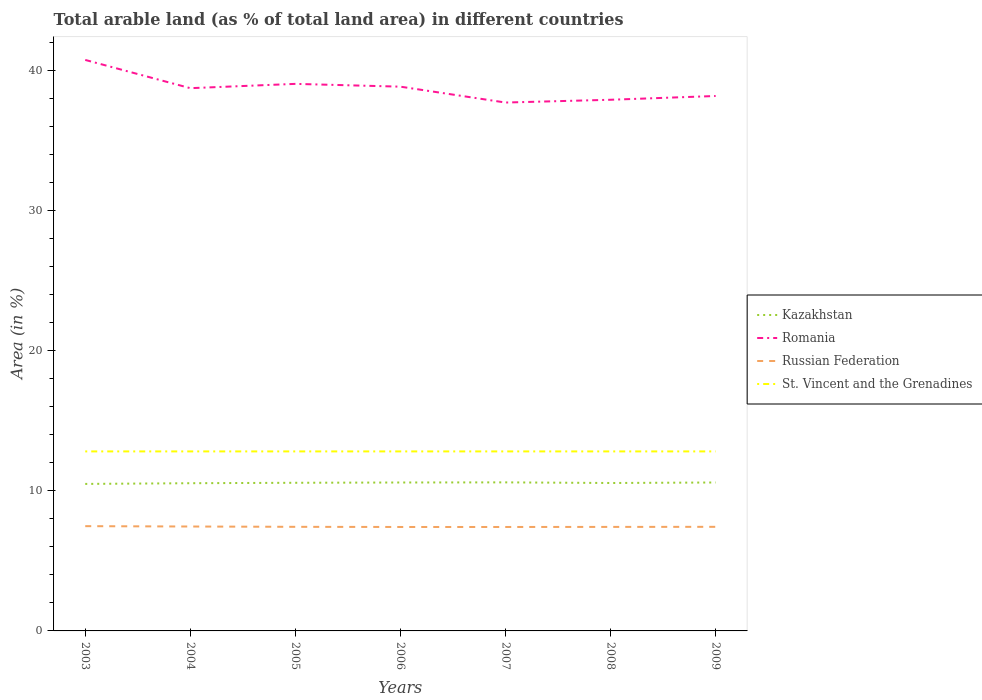How many different coloured lines are there?
Ensure brevity in your answer.  4. Across all years, what is the maximum percentage of arable land in Romania?
Your answer should be very brief. 37.74. In which year was the percentage of arable land in St. Vincent and the Grenadines maximum?
Provide a succinct answer. 2003. What is the total percentage of arable land in Russian Federation in the graph?
Keep it short and to the point. 0.01. What is the difference between the highest and the second highest percentage of arable land in Russian Federation?
Your answer should be very brief. 0.06. What is the difference between the highest and the lowest percentage of arable land in Kazakhstan?
Your answer should be compact. 4. Is the percentage of arable land in Romania strictly greater than the percentage of arable land in Kazakhstan over the years?
Provide a succinct answer. No. How many lines are there?
Your response must be concise. 4. How many years are there in the graph?
Provide a short and direct response. 7. What is the difference between two consecutive major ticks on the Y-axis?
Ensure brevity in your answer.  10. Does the graph contain any zero values?
Ensure brevity in your answer.  No. How many legend labels are there?
Offer a very short reply. 4. What is the title of the graph?
Offer a terse response. Total arable land (as % of total land area) in different countries. Does "Greece" appear as one of the legend labels in the graph?
Offer a very short reply. No. What is the label or title of the Y-axis?
Offer a very short reply. Area (in %). What is the Area (in %) in Kazakhstan in 2003?
Provide a succinct answer. 10.5. What is the Area (in %) in Romania in 2003?
Give a very brief answer. 40.78. What is the Area (in %) of Russian Federation in 2003?
Keep it short and to the point. 7.48. What is the Area (in %) in St. Vincent and the Grenadines in 2003?
Provide a short and direct response. 12.82. What is the Area (in %) of Kazakhstan in 2004?
Provide a succinct answer. 10.55. What is the Area (in %) in Romania in 2004?
Keep it short and to the point. 38.76. What is the Area (in %) in Russian Federation in 2004?
Your response must be concise. 7.46. What is the Area (in %) in St. Vincent and the Grenadines in 2004?
Provide a succinct answer. 12.82. What is the Area (in %) in Kazakhstan in 2005?
Your response must be concise. 10.58. What is the Area (in %) in Romania in 2005?
Your answer should be very brief. 39.07. What is the Area (in %) of Russian Federation in 2005?
Your response must be concise. 7.43. What is the Area (in %) in St. Vincent and the Grenadines in 2005?
Offer a terse response. 12.82. What is the Area (in %) of Kazakhstan in 2006?
Provide a succinct answer. 10.6. What is the Area (in %) of Romania in 2006?
Offer a terse response. 38.87. What is the Area (in %) of Russian Federation in 2006?
Offer a terse response. 7.42. What is the Area (in %) in St. Vincent and the Grenadines in 2006?
Keep it short and to the point. 12.82. What is the Area (in %) in Kazakhstan in 2007?
Your answer should be very brief. 10.61. What is the Area (in %) of Romania in 2007?
Make the answer very short. 37.74. What is the Area (in %) of Russian Federation in 2007?
Ensure brevity in your answer.  7.42. What is the Area (in %) in St. Vincent and the Grenadines in 2007?
Ensure brevity in your answer.  12.82. What is the Area (in %) in Kazakhstan in 2008?
Give a very brief answer. 10.56. What is the Area (in %) of Romania in 2008?
Your response must be concise. 37.93. What is the Area (in %) of Russian Federation in 2008?
Give a very brief answer. 7.43. What is the Area (in %) in St. Vincent and the Grenadines in 2008?
Offer a very short reply. 12.82. What is the Area (in %) of Kazakhstan in 2009?
Your response must be concise. 10.6. What is the Area (in %) of Romania in 2009?
Your answer should be compact. 38.2. What is the Area (in %) in Russian Federation in 2009?
Your answer should be very brief. 7.43. What is the Area (in %) of St. Vincent and the Grenadines in 2009?
Provide a succinct answer. 12.82. Across all years, what is the maximum Area (in %) of Kazakhstan?
Make the answer very short. 10.61. Across all years, what is the maximum Area (in %) of Romania?
Make the answer very short. 40.78. Across all years, what is the maximum Area (in %) in Russian Federation?
Your answer should be very brief. 7.48. Across all years, what is the maximum Area (in %) of St. Vincent and the Grenadines?
Your answer should be compact. 12.82. Across all years, what is the minimum Area (in %) in Kazakhstan?
Your answer should be compact. 10.5. Across all years, what is the minimum Area (in %) in Romania?
Provide a short and direct response. 37.74. Across all years, what is the minimum Area (in %) of Russian Federation?
Make the answer very short. 7.42. Across all years, what is the minimum Area (in %) of St. Vincent and the Grenadines?
Your answer should be compact. 12.82. What is the total Area (in %) in Kazakhstan in the graph?
Offer a very short reply. 74. What is the total Area (in %) in Romania in the graph?
Ensure brevity in your answer.  271.35. What is the total Area (in %) of Russian Federation in the graph?
Provide a short and direct response. 52.08. What is the total Area (in %) of St. Vincent and the Grenadines in the graph?
Your answer should be very brief. 89.74. What is the difference between the Area (in %) of Kazakhstan in 2003 and that in 2004?
Provide a succinct answer. -0.05. What is the difference between the Area (in %) in Romania in 2003 and that in 2004?
Provide a succinct answer. 2.02. What is the difference between the Area (in %) of Russian Federation in 2003 and that in 2004?
Offer a very short reply. 0.03. What is the difference between the Area (in %) of St. Vincent and the Grenadines in 2003 and that in 2004?
Offer a very short reply. 0. What is the difference between the Area (in %) in Kazakhstan in 2003 and that in 2005?
Give a very brief answer. -0.08. What is the difference between the Area (in %) of Romania in 2003 and that in 2005?
Give a very brief answer. 1.71. What is the difference between the Area (in %) in Russian Federation in 2003 and that in 2005?
Your answer should be very brief. 0.05. What is the difference between the Area (in %) in Kazakhstan in 2003 and that in 2006?
Keep it short and to the point. -0.1. What is the difference between the Area (in %) in Romania in 2003 and that in 2006?
Offer a terse response. 1.91. What is the difference between the Area (in %) of Russian Federation in 2003 and that in 2006?
Your response must be concise. 0.06. What is the difference between the Area (in %) in St. Vincent and the Grenadines in 2003 and that in 2006?
Keep it short and to the point. 0. What is the difference between the Area (in %) of Kazakhstan in 2003 and that in 2007?
Provide a short and direct response. -0.11. What is the difference between the Area (in %) of Romania in 2003 and that in 2007?
Ensure brevity in your answer.  3.04. What is the difference between the Area (in %) of Russian Federation in 2003 and that in 2007?
Your answer should be very brief. 0.06. What is the difference between the Area (in %) of St. Vincent and the Grenadines in 2003 and that in 2007?
Your answer should be very brief. 0. What is the difference between the Area (in %) in Kazakhstan in 2003 and that in 2008?
Offer a very short reply. -0.07. What is the difference between the Area (in %) of Romania in 2003 and that in 2008?
Your answer should be very brief. 2.84. What is the difference between the Area (in %) in Russian Federation in 2003 and that in 2008?
Your answer should be very brief. 0.05. What is the difference between the Area (in %) in St. Vincent and the Grenadines in 2003 and that in 2008?
Your answer should be compact. 0. What is the difference between the Area (in %) in Kazakhstan in 2003 and that in 2009?
Keep it short and to the point. -0.1. What is the difference between the Area (in %) of Romania in 2003 and that in 2009?
Offer a very short reply. 2.58. What is the difference between the Area (in %) of Russian Federation in 2003 and that in 2009?
Make the answer very short. 0.05. What is the difference between the Area (in %) of Kazakhstan in 2004 and that in 2005?
Keep it short and to the point. -0.03. What is the difference between the Area (in %) of Romania in 2004 and that in 2005?
Provide a succinct answer. -0.31. What is the difference between the Area (in %) of Russian Federation in 2004 and that in 2005?
Ensure brevity in your answer.  0.02. What is the difference between the Area (in %) in St. Vincent and the Grenadines in 2004 and that in 2005?
Keep it short and to the point. 0. What is the difference between the Area (in %) of Kazakhstan in 2004 and that in 2006?
Your answer should be compact. -0.05. What is the difference between the Area (in %) in Romania in 2004 and that in 2006?
Your answer should be very brief. -0.11. What is the difference between the Area (in %) of Kazakhstan in 2004 and that in 2007?
Offer a terse response. -0.06. What is the difference between the Area (in %) of Romania in 2004 and that in 2007?
Your answer should be compact. 1.03. What is the difference between the Area (in %) in St. Vincent and the Grenadines in 2004 and that in 2007?
Provide a succinct answer. 0. What is the difference between the Area (in %) of Kazakhstan in 2004 and that in 2008?
Offer a terse response. -0.02. What is the difference between the Area (in %) of Romania in 2004 and that in 2008?
Your answer should be very brief. 0.83. What is the difference between the Area (in %) of Russian Federation in 2004 and that in 2008?
Ensure brevity in your answer.  0.03. What is the difference between the Area (in %) in Kazakhstan in 2004 and that in 2009?
Provide a short and direct response. -0.05. What is the difference between the Area (in %) of Romania in 2004 and that in 2009?
Offer a very short reply. 0.56. What is the difference between the Area (in %) in Russian Federation in 2004 and that in 2009?
Your response must be concise. 0.02. What is the difference between the Area (in %) of Kazakhstan in 2005 and that in 2006?
Your response must be concise. -0.02. What is the difference between the Area (in %) in Russian Federation in 2005 and that in 2006?
Your answer should be compact. 0.01. What is the difference between the Area (in %) in St. Vincent and the Grenadines in 2005 and that in 2006?
Keep it short and to the point. 0. What is the difference between the Area (in %) in Kazakhstan in 2005 and that in 2007?
Ensure brevity in your answer.  -0.03. What is the difference between the Area (in %) of Romania in 2005 and that in 2007?
Give a very brief answer. 1.33. What is the difference between the Area (in %) of Russian Federation in 2005 and that in 2007?
Offer a terse response. 0.01. What is the difference between the Area (in %) of Kazakhstan in 2005 and that in 2008?
Ensure brevity in your answer.  0.02. What is the difference between the Area (in %) in Romania in 2005 and that in 2008?
Keep it short and to the point. 1.13. What is the difference between the Area (in %) in Russian Federation in 2005 and that in 2008?
Your response must be concise. 0.01. What is the difference between the Area (in %) of Kazakhstan in 2005 and that in 2009?
Provide a succinct answer. -0.02. What is the difference between the Area (in %) of Romania in 2005 and that in 2009?
Make the answer very short. 0.87. What is the difference between the Area (in %) of Russian Federation in 2005 and that in 2009?
Provide a succinct answer. -0. What is the difference between the Area (in %) in Kazakhstan in 2006 and that in 2007?
Give a very brief answer. -0.01. What is the difference between the Area (in %) of Romania in 2006 and that in 2007?
Your answer should be very brief. 1.13. What is the difference between the Area (in %) in Russian Federation in 2006 and that in 2007?
Make the answer very short. 0. What is the difference between the Area (in %) in St. Vincent and the Grenadines in 2006 and that in 2007?
Your response must be concise. 0. What is the difference between the Area (in %) of Kazakhstan in 2006 and that in 2008?
Provide a short and direct response. 0.04. What is the difference between the Area (in %) of Romania in 2006 and that in 2008?
Give a very brief answer. 0.93. What is the difference between the Area (in %) in Russian Federation in 2006 and that in 2008?
Keep it short and to the point. -0.01. What is the difference between the Area (in %) in St. Vincent and the Grenadines in 2006 and that in 2008?
Offer a terse response. 0. What is the difference between the Area (in %) in Kazakhstan in 2006 and that in 2009?
Provide a short and direct response. -0. What is the difference between the Area (in %) in Romania in 2006 and that in 2009?
Make the answer very short. 0.67. What is the difference between the Area (in %) of Russian Federation in 2006 and that in 2009?
Give a very brief answer. -0.01. What is the difference between the Area (in %) of St. Vincent and the Grenadines in 2006 and that in 2009?
Offer a very short reply. 0. What is the difference between the Area (in %) in Kazakhstan in 2007 and that in 2008?
Your answer should be compact. 0.04. What is the difference between the Area (in %) in Romania in 2007 and that in 2008?
Provide a succinct answer. -0.2. What is the difference between the Area (in %) in Russian Federation in 2007 and that in 2008?
Keep it short and to the point. -0.01. What is the difference between the Area (in %) of St. Vincent and the Grenadines in 2007 and that in 2008?
Your answer should be very brief. 0. What is the difference between the Area (in %) in Kazakhstan in 2007 and that in 2009?
Offer a terse response. 0.01. What is the difference between the Area (in %) in Romania in 2007 and that in 2009?
Provide a short and direct response. -0.47. What is the difference between the Area (in %) in Russian Federation in 2007 and that in 2009?
Make the answer very short. -0.01. What is the difference between the Area (in %) in St. Vincent and the Grenadines in 2007 and that in 2009?
Offer a very short reply. 0. What is the difference between the Area (in %) of Kazakhstan in 2008 and that in 2009?
Your answer should be very brief. -0.04. What is the difference between the Area (in %) in Romania in 2008 and that in 2009?
Your answer should be compact. -0.27. What is the difference between the Area (in %) in Russian Federation in 2008 and that in 2009?
Offer a very short reply. -0.01. What is the difference between the Area (in %) in St. Vincent and the Grenadines in 2008 and that in 2009?
Your answer should be very brief. 0. What is the difference between the Area (in %) in Kazakhstan in 2003 and the Area (in %) in Romania in 2004?
Offer a very short reply. -28.26. What is the difference between the Area (in %) of Kazakhstan in 2003 and the Area (in %) of Russian Federation in 2004?
Provide a succinct answer. 3.04. What is the difference between the Area (in %) in Kazakhstan in 2003 and the Area (in %) in St. Vincent and the Grenadines in 2004?
Your answer should be compact. -2.32. What is the difference between the Area (in %) of Romania in 2003 and the Area (in %) of Russian Federation in 2004?
Your answer should be very brief. 33.32. What is the difference between the Area (in %) of Romania in 2003 and the Area (in %) of St. Vincent and the Grenadines in 2004?
Your response must be concise. 27.96. What is the difference between the Area (in %) of Russian Federation in 2003 and the Area (in %) of St. Vincent and the Grenadines in 2004?
Make the answer very short. -5.34. What is the difference between the Area (in %) of Kazakhstan in 2003 and the Area (in %) of Romania in 2005?
Your answer should be very brief. -28.57. What is the difference between the Area (in %) in Kazakhstan in 2003 and the Area (in %) in Russian Federation in 2005?
Provide a short and direct response. 3.06. What is the difference between the Area (in %) in Kazakhstan in 2003 and the Area (in %) in St. Vincent and the Grenadines in 2005?
Provide a short and direct response. -2.32. What is the difference between the Area (in %) in Romania in 2003 and the Area (in %) in Russian Federation in 2005?
Ensure brevity in your answer.  33.34. What is the difference between the Area (in %) in Romania in 2003 and the Area (in %) in St. Vincent and the Grenadines in 2005?
Provide a short and direct response. 27.96. What is the difference between the Area (in %) of Russian Federation in 2003 and the Area (in %) of St. Vincent and the Grenadines in 2005?
Give a very brief answer. -5.34. What is the difference between the Area (in %) in Kazakhstan in 2003 and the Area (in %) in Romania in 2006?
Your response must be concise. -28.37. What is the difference between the Area (in %) of Kazakhstan in 2003 and the Area (in %) of Russian Federation in 2006?
Offer a very short reply. 3.08. What is the difference between the Area (in %) of Kazakhstan in 2003 and the Area (in %) of St. Vincent and the Grenadines in 2006?
Your response must be concise. -2.32. What is the difference between the Area (in %) of Romania in 2003 and the Area (in %) of Russian Federation in 2006?
Offer a very short reply. 33.36. What is the difference between the Area (in %) in Romania in 2003 and the Area (in %) in St. Vincent and the Grenadines in 2006?
Provide a short and direct response. 27.96. What is the difference between the Area (in %) in Russian Federation in 2003 and the Area (in %) in St. Vincent and the Grenadines in 2006?
Provide a succinct answer. -5.34. What is the difference between the Area (in %) of Kazakhstan in 2003 and the Area (in %) of Romania in 2007?
Your response must be concise. -27.24. What is the difference between the Area (in %) of Kazakhstan in 2003 and the Area (in %) of Russian Federation in 2007?
Offer a terse response. 3.08. What is the difference between the Area (in %) in Kazakhstan in 2003 and the Area (in %) in St. Vincent and the Grenadines in 2007?
Keep it short and to the point. -2.32. What is the difference between the Area (in %) in Romania in 2003 and the Area (in %) in Russian Federation in 2007?
Keep it short and to the point. 33.36. What is the difference between the Area (in %) in Romania in 2003 and the Area (in %) in St. Vincent and the Grenadines in 2007?
Keep it short and to the point. 27.96. What is the difference between the Area (in %) in Russian Federation in 2003 and the Area (in %) in St. Vincent and the Grenadines in 2007?
Ensure brevity in your answer.  -5.34. What is the difference between the Area (in %) of Kazakhstan in 2003 and the Area (in %) of Romania in 2008?
Provide a short and direct response. -27.44. What is the difference between the Area (in %) in Kazakhstan in 2003 and the Area (in %) in Russian Federation in 2008?
Make the answer very short. 3.07. What is the difference between the Area (in %) of Kazakhstan in 2003 and the Area (in %) of St. Vincent and the Grenadines in 2008?
Keep it short and to the point. -2.32. What is the difference between the Area (in %) of Romania in 2003 and the Area (in %) of Russian Federation in 2008?
Offer a terse response. 33.35. What is the difference between the Area (in %) of Romania in 2003 and the Area (in %) of St. Vincent and the Grenadines in 2008?
Your answer should be compact. 27.96. What is the difference between the Area (in %) of Russian Federation in 2003 and the Area (in %) of St. Vincent and the Grenadines in 2008?
Your response must be concise. -5.34. What is the difference between the Area (in %) of Kazakhstan in 2003 and the Area (in %) of Romania in 2009?
Ensure brevity in your answer.  -27.7. What is the difference between the Area (in %) of Kazakhstan in 2003 and the Area (in %) of Russian Federation in 2009?
Provide a succinct answer. 3.06. What is the difference between the Area (in %) in Kazakhstan in 2003 and the Area (in %) in St. Vincent and the Grenadines in 2009?
Your response must be concise. -2.32. What is the difference between the Area (in %) in Romania in 2003 and the Area (in %) in Russian Federation in 2009?
Make the answer very short. 33.34. What is the difference between the Area (in %) of Romania in 2003 and the Area (in %) of St. Vincent and the Grenadines in 2009?
Give a very brief answer. 27.96. What is the difference between the Area (in %) in Russian Federation in 2003 and the Area (in %) in St. Vincent and the Grenadines in 2009?
Your answer should be very brief. -5.34. What is the difference between the Area (in %) of Kazakhstan in 2004 and the Area (in %) of Romania in 2005?
Provide a short and direct response. -28.52. What is the difference between the Area (in %) in Kazakhstan in 2004 and the Area (in %) in Russian Federation in 2005?
Offer a very short reply. 3.11. What is the difference between the Area (in %) of Kazakhstan in 2004 and the Area (in %) of St. Vincent and the Grenadines in 2005?
Offer a terse response. -2.27. What is the difference between the Area (in %) in Romania in 2004 and the Area (in %) in Russian Federation in 2005?
Your answer should be compact. 31.33. What is the difference between the Area (in %) in Romania in 2004 and the Area (in %) in St. Vincent and the Grenadines in 2005?
Give a very brief answer. 25.94. What is the difference between the Area (in %) of Russian Federation in 2004 and the Area (in %) of St. Vincent and the Grenadines in 2005?
Offer a very short reply. -5.36. What is the difference between the Area (in %) of Kazakhstan in 2004 and the Area (in %) of Romania in 2006?
Make the answer very short. -28.32. What is the difference between the Area (in %) of Kazakhstan in 2004 and the Area (in %) of Russian Federation in 2006?
Make the answer very short. 3.13. What is the difference between the Area (in %) in Kazakhstan in 2004 and the Area (in %) in St. Vincent and the Grenadines in 2006?
Offer a very short reply. -2.27. What is the difference between the Area (in %) in Romania in 2004 and the Area (in %) in Russian Federation in 2006?
Your answer should be compact. 31.34. What is the difference between the Area (in %) of Romania in 2004 and the Area (in %) of St. Vincent and the Grenadines in 2006?
Make the answer very short. 25.94. What is the difference between the Area (in %) in Russian Federation in 2004 and the Area (in %) in St. Vincent and the Grenadines in 2006?
Make the answer very short. -5.36. What is the difference between the Area (in %) in Kazakhstan in 2004 and the Area (in %) in Romania in 2007?
Your answer should be very brief. -27.19. What is the difference between the Area (in %) of Kazakhstan in 2004 and the Area (in %) of Russian Federation in 2007?
Offer a very short reply. 3.13. What is the difference between the Area (in %) of Kazakhstan in 2004 and the Area (in %) of St. Vincent and the Grenadines in 2007?
Your answer should be very brief. -2.27. What is the difference between the Area (in %) in Romania in 2004 and the Area (in %) in Russian Federation in 2007?
Your response must be concise. 31.34. What is the difference between the Area (in %) of Romania in 2004 and the Area (in %) of St. Vincent and the Grenadines in 2007?
Your response must be concise. 25.94. What is the difference between the Area (in %) in Russian Federation in 2004 and the Area (in %) in St. Vincent and the Grenadines in 2007?
Your response must be concise. -5.36. What is the difference between the Area (in %) of Kazakhstan in 2004 and the Area (in %) of Romania in 2008?
Your answer should be very brief. -27.39. What is the difference between the Area (in %) of Kazakhstan in 2004 and the Area (in %) of Russian Federation in 2008?
Your response must be concise. 3.12. What is the difference between the Area (in %) of Kazakhstan in 2004 and the Area (in %) of St. Vincent and the Grenadines in 2008?
Offer a very short reply. -2.27. What is the difference between the Area (in %) in Romania in 2004 and the Area (in %) in Russian Federation in 2008?
Your answer should be compact. 31.33. What is the difference between the Area (in %) in Romania in 2004 and the Area (in %) in St. Vincent and the Grenadines in 2008?
Offer a terse response. 25.94. What is the difference between the Area (in %) of Russian Federation in 2004 and the Area (in %) of St. Vincent and the Grenadines in 2008?
Provide a succinct answer. -5.36. What is the difference between the Area (in %) of Kazakhstan in 2004 and the Area (in %) of Romania in 2009?
Your answer should be very brief. -27.65. What is the difference between the Area (in %) in Kazakhstan in 2004 and the Area (in %) in Russian Federation in 2009?
Your answer should be very brief. 3.11. What is the difference between the Area (in %) of Kazakhstan in 2004 and the Area (in %) of St. Vincent and the Grenadines in 2009?
Make the answer very short. -2.27. What is the difference between the Area (in %) in Romania in 2004 and the Area (in %) in Russian Federation in 2009?
Keep it short and to the point. 31.33. What is the difference between the Area (in %) of Romania in 2004 and the Area (in %) of St. Vincent and the Grenadines in 2009?
Offer a terse response. 25.94. What is the difference between the Area (in %) in Russian Federation in 2004 and the Area (in %) in St. Vincent and the Grenadines in 2009?
Give a very brief answer. -5.36. What is the difference between the Area (in %) in Kazakhstan in 2005 and the Area (in %) in Romania in 2006?
Provide a succinct answer. -28.29. What is the difference between the Area (in %) of Kazakhstan in 2005 and the Area (in %) of Russian Federation in 2006?
Your answer should be compact. 3.16. What is the difference between the Area (in %) of Kazakhstan in 2005 and the Area (in %) of St. Vincent and the Grenadines in 2006?
Your answer should be very brief. -2.24. What is the difference between the Area (in %) in Romania in 2005 and the Area (in %) in Russian Federation in 2006?
Make the answer very short. 31.65. What is the difference between the Area (in %) in Romania in 2005 and the Area (in %) in St. Vincent and the Grenadines in 2006?
Your answer should be very brief. 26.25. What is the difference between the Area (in %) of Russian Federation in 2005 and the Area (in %) of St. Vincent and the Grenadines in 2006?
Your response must be concise. -5.39. What is the difference between the Area (in %) in Kazakhstan in 2005 and the Area (in %) in Romania in 2007?
Your response must be concise. -27.16. What is the difference between the Area (in %) in Kazakhstan in 2005 and the Area (in %) in Russian Federation in 2007?
Provide a succinct answer. 3.16. What is the difference between the Area (in %) of Kazakhstan in 2005 and the Area (in %) of St. Vincent and the Grenadines in 2007?
Ensure brevity in your answer.  -2.24. What is the difference between the Area (in %) of Romania in 2005 and the Area (in %) of Russian Federation in 2007?
Make the answer very short. 31.65. What is the difference between the Area (in %) in Romania in 2005 and the Area (in %) in St. Vincent and the Grenadines in 2007?
Give a very brief answer. 26.25. What is the difference between the Area (in %) of Russian Federation in 2005 and the Area (in %) of St. Vincent and the Grenadines in 2007?
Keep it short and to the point. -5.39. What is the difference between the Area (in %) in Kazakhstan in 2005 and the Area (in %) in Romania in 2008?
Your answer should be compact. -27.35. What is the difference between the Area (in %) in Kazakhstan in 2005 and the Area (in %) in Russian Federation in 2008?
Ensure brevity in your answer.  3.15. What is the difference between the Area (in %) of Kazakhstan in 2005 and the Area (in %) of St. Vincent and the Grenadines in 2008?
Offer a very short reply. -2.24. What is the difference between the Area (in %) in Romania in 2005 and the Area (in %) in Russian Federation in 2008?
Your answer should be compact. 31.64. What is the difference between the Area (in %) of Romania in 2005 and the Area (in %) of St. Vincent and the Grenadines in 2008?
Provide a succinct answer. 26.25. What is the difference between the Area (in %) of Russian Federation in 2005 and the Area (in %) of St. Vincent and the Grenadines in 2008?
Your answer should be compact. -5.39. What is the difference between the Area (in %) in Kazakhstan in 2005 and the Area (in %) in Romania in 2009?
Give a very brief answer. -27.62. What is the difference between the Area (in %) of Kazakhstan in 2005 and the Area (in %) of Russian Federation in 2009?
Provide a short and direct response. 3.15. What is the difference between the Area (in %) in Kazakhstan in 2005 and the Area (in %) in St. Vincent and the Grenadines in 2009?
Your answer should be compact. -2.24. What is the difference between the Area (in %) in Romania in 2005 and the Area (in %) in Russian Federation in 2009?
Your answer should be very brief. 31.63. What is the difference between the Area (in %) in Romania in 2005 and the Area (in %) in St. Vincent and the Grenadines in 2009?
Keep it short and to the point. 26.25. What is the difference between the Area (in %) in Russian Federation in 2005 and the Area (in %) in St. Vincent and the Grenadines in 2009?
Your response must be concise. -5.39. What is the difference between the Area (in %) of Kazakhstan in 2006 and the Area (in %) of Romania in 2007?
Offer a very short reply. -27.14. What is the difference between the Area (in %) in Kazakhstan in 2006 and the Area (in %) in Russian Federation in 2007?
Provide a short and direct response. 3.18. What is the difference between the Area (in %) of Kazakhstan in 2006 and the Area (in %) of St. Vincent and the Grenadines in 2007?
Offer a very short reply. -2.22. What is the difference between the Area (in %) in Romania in 2006 and the Area (in %) in Russian Federation in 2007?
Your answer should be compact. 31.45. What is the difference between the Area (in %) in Romania in 2006 and the Area (in %) in St. Vincent and the Grenadines in 2007?
Your response must be concise. 26.05. What is the difference between the Area (in %) of Russian Federation in 2006 and the Area (in %) of St. Vincent and the Grenadines in 2007?
Offer a terse response. -5.4. What is the difference between the Area (in %) of Kazakhstan in 2006 and the Area (in %) of Romania in 2008?
Your response must be concise. -27.33. What is the difference between the Area (in %) in Kazakhstan in 2006 and the Area (in %) in Russian Federation in 2008?
Give a very brief answer. 3.17. What is the difference between the Area (in %) in Kazakhstan in 2006 and the Area (in %) in St. Vincent and the Grenadines in 2008?
Provide a short and direct response. -2.22. What is the difference between the Area (in %) of Romania in 2006 and the Area (in %) of Russian Federation in 2008?
Your answer should be very brief. 31.44. What is the difference between the Area (in %) of Romania in 2006 and the Area (in %) of St. Vincent and the Grenadines in 2008?
Your answer should be compact. 26.05. What is the difference between the Area (in %) of Russian Federation in 2006 and the Area (in %) of St. Vincent and the Grenadines in 2008?
Offer a terse response. -5.4. What is the difference between the Area (in %) in Kazakhstan in 2006 and the Area (in %) in Romania in 2009?
Provide a succinct answer. -27.6. What is the difference between the Area (in %) of Kazakhstan in 2006 and the Area (in %) of Russian Federation in 2009?
Provide a short and direct response. 3.17. What is the difference between the Area (in %) in Kazakhstan in 2006 and the Area (in %) in St. Vincent and the Grenadines in 2009?
Your response must be concise. -2.22. What is the difference between the Area (in %) of Romania in 2006 and the Area (in %) of Russian Federation in 2009?
Provide a short and direct response. 31.43. What is the difference between the Area (in %) of Romania in 2006 and the Area (in %) of St. Vincent and the Grenadines in 2009?
Your response must be concise. 26.05. What is the difference between the Area (in %) in Russian Federation in 2006 and the Area (in %) in St. Vincent and the Grenadines in 2009?
Your response must be concise. -5.4. What is the difference between the Area (in %) of Kazakhstan in 2007 and the Area (in %) of Romania in 2008?
Ensure brevity in your answer.  -27.32. What is the difference between the Area (in %) in Kazakhstan in 2007 and the Area (in %) in Russian Federation in 2008?
Your answer should be very brief. 3.18. What is the difference between the Area (in %) in Kazakhstan in 2007 and the Area (in %) in St. Vincent and the Grenadines in 2008?
Provide a succinct answer. -2.21. What is the difference between the Area (in %) of Romania in 2007 and the Area (in %) of Russian Federation in 2008?
Offer a terse response. 30.31. What is the difference between the Area (in %) in Romania in 2007 and the Area (in %) in St. Vincent and the Grenadines in 2008?
Your answer should be very brief. 24.91. What is the difference between the Area (in %) of Russian Federation in 2007 and the Area (in %) of St. Vincent and the Grenadines in 2008?
Your response must be concise. -5.4. What is the difference between the Area (in %) in Kazakhstan in 2007 and the Area (in %) in Romania in 2009?
Your response must be concise. -27.59. What is the difference between the Area (in %) in Kazakhstan in 2007 and the Area (in %) in Russian Federation in 2009?
Make the answer very short. 3.17. What is the difference between the Area (in %) of Kazakhstan in 2007 and the Area (in %) of St. Vincent and the Grenadines in 2009?
Give a very brief answer. -2.21. What is the difference between the Area (in %) of Romania in 2007 and the Area (in %) of Russian Federation in 2009?
Give a very brief answer. 30.3. What is the difference between the Area (in %) of Romania in 2007 and the Area (in %) of St. Vincent and the Grenadines in 2009?
Provide a succinct answer. 24.91. What is the difference between the Area (in %) in Russian Federation in 2007 and the Area (in %) in St. Vincent and the Grenadines in 2009?
Your answer should be very brief. -5.4. What is the difference between the Area (in %) of Kazakhstan in 2008 and the Area (in %) of Romania in 2009?
Offer a terse response. -27.64. What is the difference between the Area (in %) of Kazakhstan in 2008 and the Area (in %) of Russian Federation in 2009?
Ensure brevity in your answer.  3.13. What is the difference between the Area (in %) of Kazakhstan in 2008 and the Area (in %) of St. Vincent and the Grenadines in 2009?
Offer a very short reply. -2.26. What is the difference between the Area (in %) of Romania in 2008 and the Area (in %) of Russian Federation in 2009?
Your answer should be compact. 30.5. What is the difference between the Area (in %) in Romania in 2008 and the Area (in %) in St. Vincent and the Grenadines in 2009?
Your answer should be compact. 25.11. What is the difference between the Area (in %) in Russian Federation in 2008 and the Area (in %) in St. Vincent and the Grenadines in 2009?
Your response must be concise. -5.39. What is the average Area (in %) of Kazakhstan per year?
Your answer should be compact. 10.57. What is the average Area (in %) in Romania per year?
Provide a short and direct response. 38.76. What is the average Area (in %) of Russian Federation per year?
Offer a terse response. 7.44. What is the average Area (in %) of St. Vincent and the Grenadines per year?
Provide a short and direct response. 12.82. In the year 2003, what is the difference between the Area (in %) of Kazakhstan and Area (in %) of Romania?
Provide a short and direct response. -30.28. In the year 2003, what is the difference between the Area (in %) in Kazakhstan and Area (in %) in Russian Federation?
Offer a terse response. 3.02. In the year 2003, what is the difference between the Area (in %) of Kazakhstan and Area (in %) of St. Vincent and the Grenadines?
Ensure brevity in your answer.  -2.32. In the year 2003, what is the difference between the Area (in %) in Romania and Area (in %) in Russian Federation?
Give a very brief answer. 33.3. In the year 2003, what is the difference between the Area (in %) of Romania and Area (in %) of St. Vincent and the Grenadines?
Give a very brief answer. 27.96. In the year 2003, what is the difference between the Area (in %) in Russian Federation and Area (in %) in St. Vincent and the Grenadines?
Your response must be concise. -5.34. In the year 2004, what is the difference between the Area (in %) in Kazakhstan and Area (in %) in Romania?
Offer a terse response. -28.21. In the year 2004, what is the difference between the Area (in %) of Kazakhstan and Area (in %) of Russian Federation?
Offer a terse response. 3.09. In the year 2004, what is the difference between the Area (in %) of Kazakhstan and Area (in %) of St. Vincent and the Grenadines?
Your response must be concise. -2.27. In the year 2004, what is the difference between the Area (in %) in Romania and Area (in %) in Russian Federation?
Give a very brief answer. 31.3. In the year 2004, what is the difference between the Area (in %) in Romania and Area (in %) in St. Vincent and the Grenadines?
Offer a terse response. 25.94. In the year 2004, what is the difference between the Area (in %) of Russian Federation and Area (in %) of St. Vincent and the Grenadines?
Provide a short and direct response. -5.36. In the year 2005, what is the difference between the Area (in %) of Kazakhstan and Area (in %) of Romania?
Keep it short and to the point. -28.49. In the year 2005, what is the difference between the Area (in %) in Kazakhstan and Area (in %) in Russian Federation?
Your answer should be compact. 3.15. In the year 2005, what is the difference between the Area (in %) in Kazakhstan and Area (in %) in St. Vincent and the Grenadines?
Offer a terse response. -2.24. In the year 2005, what is the difference between the Area (in %) in Romania and Area (in %) in Russian Federation?
Your answer should be very brief. 31.63. In the year 2005, what is the difference between the Area (in %) in Romania and Area (in %) in St. Vincent and the Grenadines?
Ensure brevity in your answer.  26.25. In the year 2005, what is the difference between the Area (in %) of Russian Federation and Area (in %) of St. Vincent and the Grenadines?
Make the answer very short. -5.39. In the year 2006, what is the difference between the Area (in %) of Kazakhstan and Area (in %) of Romania?
Give a very brief answer. -28.27. In the year 2006, what is the difference between the Area (in %) of Kazakhstan and Area (in %) of Russian Federation?
Your answer should be very brief. 3.18. In the year 2006, what is the difference between the Area (in %) of Kazakhstan and Area (in %) of St. Vincent and the Grenadines?
Offer a very short reply. -2.22. In the year 2006, what is the difference between the Area (in %) in Romania and Area (in %) in Russian Federation?
Make the answer very short. 31.45. In the year 2006, what is the difference between the Area (in %) of Romania and Area (in %) of St. Vincent and the Grenadines?
Provide a succinct answer. 26.05. In the year 2006, what is the difference between the Area (in %) in Russian Federation and Area (in %) in St. Vincent and the Grenadines?
Offer a terse response. -5.4. In the year 2007, what is the difference between the Area (in %) of Kazakhstan and Area (in %) of Romania?
Ensure brevity in your answer.  -27.13. In the year 2007, what is the difference between the Area (in %) of Kazakhstan and Area (in %) of Russian Federation?
Make the answer very short. 3.19. In the year 2007, what is the difference between the Area (in %) of Kazakhstan and Area (in %) of St. Vincent and the Grenadines?
Offer a terse response. -2.21. In the year 2007, what is the difference between the Area (in %) in Romania and Area (in %) in Russian Federation?
Ensure brevity in your answer.  30.31. In the year 2007, what is the difference between the Area (in %) of Romania and Area (in %) of St. Vincent and the Grenadines?
Your answer should be very brief. 24.91. In the year 2007, what is the difference between the Area (in %) in Russian Federation and Area (in %) in St. Vincent and the Grenadines?
Provide a short and direct response. -5.4. In the year 2008, what is the difference between the Area (in %) in Kazakhstan and Area (in %) in Romania?
Provide a succinct answer. -27.37. In the year 2008, what is the difference between the Area (in %) of Kazakhstan and Area (in %) of Russian Federation?
Provide a short and direct response. 3.14. In the year 2008, what is the difference between the Area (in %) in Kazakhstan and Area (in %) in St. Vincent and the Grenadines?
Offer a terse response. -2.26. In the year 2008, what is the difference between the Area (in %) of Romania and Area (in %) of Russian Federation?
Your answer should be very brief. 30.51. In the year 2008, what is the difference between the Area (in %) of Romania and Area (in %) of St. Vincent and the Grenadines?
Make the answer very short. 25.11. In the year 2008, what is the difference between the Area (in %) in Russian Federation and Area (in %) in St. Vincent and the Grenadines?
Provide a succinct answer. -5.39. In the year 2009, what is the difference between the Area (in %) of Kazakhstan and Area (in %) of Romania?
Your answer should be very brief. -27.6. In the year 2009, what is the difference between the Area (in %) of Kazakhstan and Area (in %) of Russian Federation?
Keep it short and to the point. 3.17. In the year 2009, what is the difference between the Area (in %) in Kazakhstan and Area (in %) in St. Vincent and the Grenadines?
Provide a short and direct response. -2.22. In the year 2009, what is the difference between the Area (in %) of Romania and Area (in %) of Russian Federation?
Make the answer very short. 30.77. In the year 2009, what is the difference between the Area (in %) of Romania and Area (in %) of St. Vincent and the Grenadines?
Your answer should be compact. 25.38. In the year 2009, what is the difference between the Area (in %) of Russian Federation and Area (in %) of St. Vincent and the Grenadines?
Your answer should be very brief. -5.39. What is the ratio of the Area (in %) of Romania in 2003 to that in 2004?
Keep it short and to the point. 1.05. What is the ratio of the Area (in %) in St. Vincent and the Grenadines in 2003 to that in 2004?
Your response must be concise. 1. What is the ratio of the Area (in %) in Romania in 2003 to that in 2005?
Offer a very short reply. 1.04. What is the ratio of the Area (in %) in Russian Federation in 2003 to that in 2005?
Offer a very short reply. 1.01. What is the ratio of the Area (in %) in St. Vincent and the Grenadines in 2003 to that in 2005?
Make the answer very short. 1. What is the ratio of the Area (in %) in Romania in 2003 to that in 2006?
Your answer should be compact. 1.05. What is the ratio of the Area (in %) of Russian Federation in 2003 to that in 2006?
Offer a very short reply. 1.01. What is the ratio of the Area (in %) in St. Vincent and the Grenadines in 2003 to that in 2006?
Your response must be concise. 1. What is the ratio of the Area (in %) of Kazakhstan in 2003 to that in 2007?
Your response must be concise. 0.99. What is the ratio of the Area (in %) in Romania in 2003 to that in 2007?
Offer a very short reply. 1.08. What is the ratio of the Area (in %) in Russian Federation in 2003 to that in 2007?
Provide a succinct answer. 1.01. What is the ratio of the Area (in %) in Romania in 2003 to that in 2008?
Provide a succinct answer. 1.07. What is the ratio of the Area (in %) of Russian Federation in 2003 to that in 2008?
Provide a succinct answer. 1.01. What is the ratio of the Area (in %) in Romania in 2003 to that in 2009?
Offer a very short reply. 1.07. What is the ratio of the Area (in %) in Russian Federation in 2003 to that in 2009?
Make the answer very short. 1.01. What is the ratio of the Area (in %) of St. Vincent and the Grenadines in 2003 to that in 2009?
Offer a terse response. 1. What is the ratio of the Area (in %) of Kazakhstan in 2004 to that in 2005?
Ensure brevity in your answer.  1. What is the ratio of the Area (in %) in Romania in 2004 to that in 2005?
Your answer should be compact. 0.99. What is the ratio of the Area (in %) of Russian Federation in 2004 to that in 2005?
Make the answer very short. 1. What is the ratio of the Area (in %) in St. Vincent and the Grenadines in 2004 to that in 2005?
Offer a terse response. 1. What is the ratio of the Area (in %) of Kazakhstan in 2004 to that in 2006?
Ensure brevity in your answer.  1. What is the ratio of the Area (in %) of Romania in 2004 to that in 2006?
Ensure brevity in your answer.  1. What is the ratio of the Area (in %) of Kazakhstan in 2004 to that in 2007?
Ensure brevity in your answer.  0.99. What is the ratio of the Area (in %) in Romania in 2004 to that in 2007?
Your answer should be compact. 1.03. What is the ratio of the Area (in %) of St. Vincent and the Grenadines in 2004 to that in 2007?
Provide a succinct answer. 1. What is the ratio of the Area (in %) in Kazakhstan in 2004 to that in 2008?
Make the answer very short. 1. What is the ratio of the Area (in %) in Romania in 2004 to that in 2008?
Provide a succinct answer. 1.02. What is the ratio of the Area (in %) in Russian Federation in 2004 to that in 2008?
Your response must be concise. 1. What is the ratio of the Area (in %) in St. Vincent and the Grenadines in 2004 to that in 2008?
Offer a terse response. 1. What is the ratio of the Area (in %) of Romania in 2004 to that in 2009?
Your answer should be very brief. 1.01. What is the ratio of the Area (in %) in Russian Federation in 2004 to that in 2009?
Provide a short and direct response. 1. What is the ratio of the Area (in %) of St. Vincent and the Grenadines in 2004 to that in 2009?
Provide a succinct answer. 1. What is the ratio of the Area (in %) of Romania in 2005 to that in 2007?
Keep it short and to the point. 1.04. What is the ratio of the Area (in %) in Russian Federation in 2005 to that in 2007?
Your answer should be compact. 1. What is the ratio of the Area (in %) of St. Vincent and the Grenadines in 2005 to that in 2007?
Provide a short and direct response. 1. What is the ratio of the Area (in %) in Romania in 2005 to that in 2008?
Your response must be concise. 1.03. What is the ratio of the Area (in %) of St. Vincent and the Grenadines in 2005 to that in 2008?
Ensure brevity in your answer.  1. What is the ratio of the Area (in %) in Kazakhstan in 2005 to that in 2009?
Offer a very short reply. 1. What is the ratio of the Area (in %) of Romania in 2005 to that in 2009?
Your response must be concise. 1.02. What is the ratio of the Area (in %) in Russian Federation in 2006 to that in 2007?
Make the answer very short. 1. What is the ratio of the Area (in %) of St. Vincent and the Grenadines in 2006 to that in 2007?
Offer a terse response. 1. What is the ratio of the Area (in %) in Romania in 2006 to that in 2008?
Give a very brief answer. 1.02. What is the ratio of the Area (in %) in Romania in 2006 to that in 2009?
Ensure brevity in your answer.  1.02. What is the ratio of the Area (in %) in Russian Federation in 2006 to that in 2009?
Make the answer very short. 1. What is the ratio of the Area (in %) in Kazakhstan in 2007 to that in 2008?
Ensure brevity in your answer.  1. What is the ratio of the Area (in %) of Russian Federation in 2007 to that in 2008?
Your answer should be compact. 1. What is the ratio of the Area (in %) of St. Vincent and the Grenadines in 2007 to that in 2008?
Offer a terse response. 1. What is the ratio of the Area (in %) in Romania in 2007 to that in 2009?
Your answer should be compact. 0.99. What is the ratio of the Area (in %) of Russian Federation in 2007 to that in 2009?
Offer a very short reply. 1. What is the ratio of the Area (in %) of Kazakhstan in 2008 to that in 2009?
Offer a very short reply. 1. What is the ratio of the Area (in %) in St. Vincent and the Grenadines in 2008 to that in 2009?
Your answer should be compact. 1. What is the difference between the highest and the second highest Area (in %) of Kazakhstan?
Keep it short and to the point. 0.01. What is the difference between the highest and the second highest Area (in %) in Romania?
Ensure brevity in your answer.  1.71. What is the difference between the highest and the second highest Area (in %) in Russian Federation?
Make the answer very short. 0.03. What is the difference between the highest and the second highest Area (in %) in St. Vincent and the Grenadines?
Give a very brief answer. 0. What is the difference between the highest and the lowest Area (in %) in Kazakhstan?
Offer a very short reply. 0.11. What is the difference between the highest and the lowest Area (in %) of Romania?
Provide a succinct answer. 3.04. What is the difference between the highest and the lowest Area (in %) in Russian Federation?
Offer a very short reply. 0.06. 